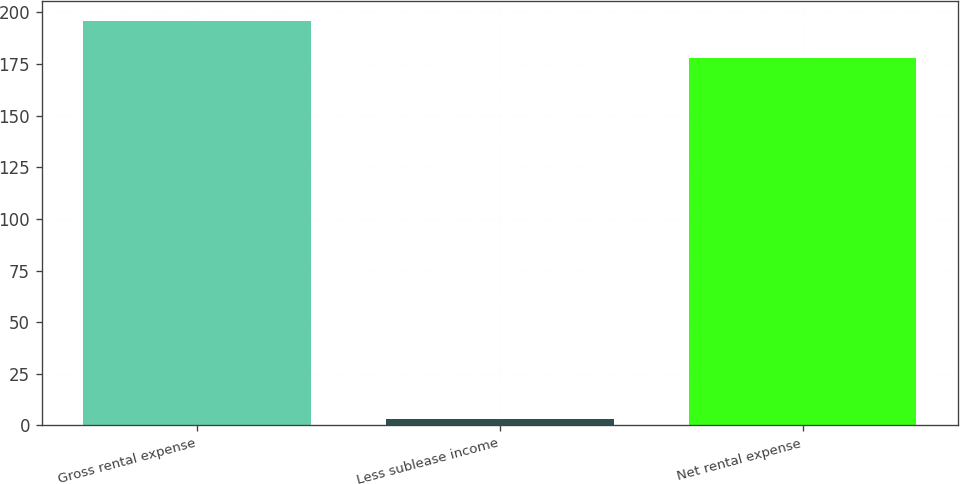Convert chart. <chart><loc_0><loc_0><loc_500><loc_500><bar_chart><fcel>Gross rental expense<fcel>Less sublease income<fcel>Net rental expense<nl><fcel>195.8<fcel>3<fcel>178<nl></chart> 